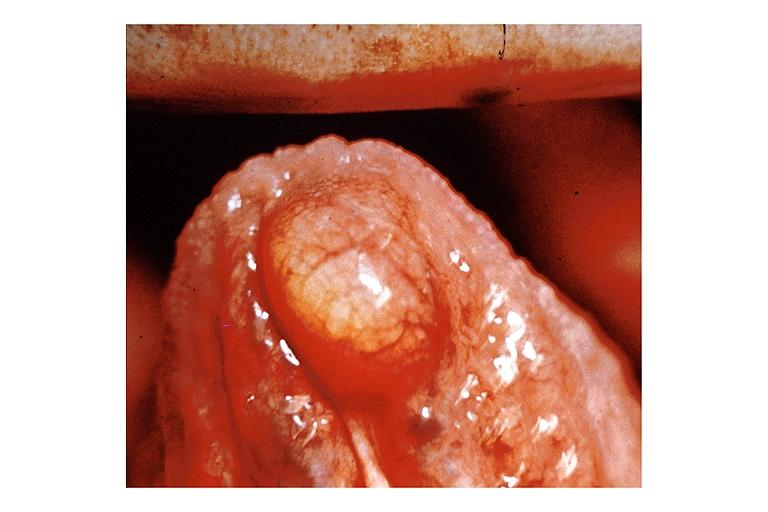what is present?
Answer the question using a single word or phrase. Oral 